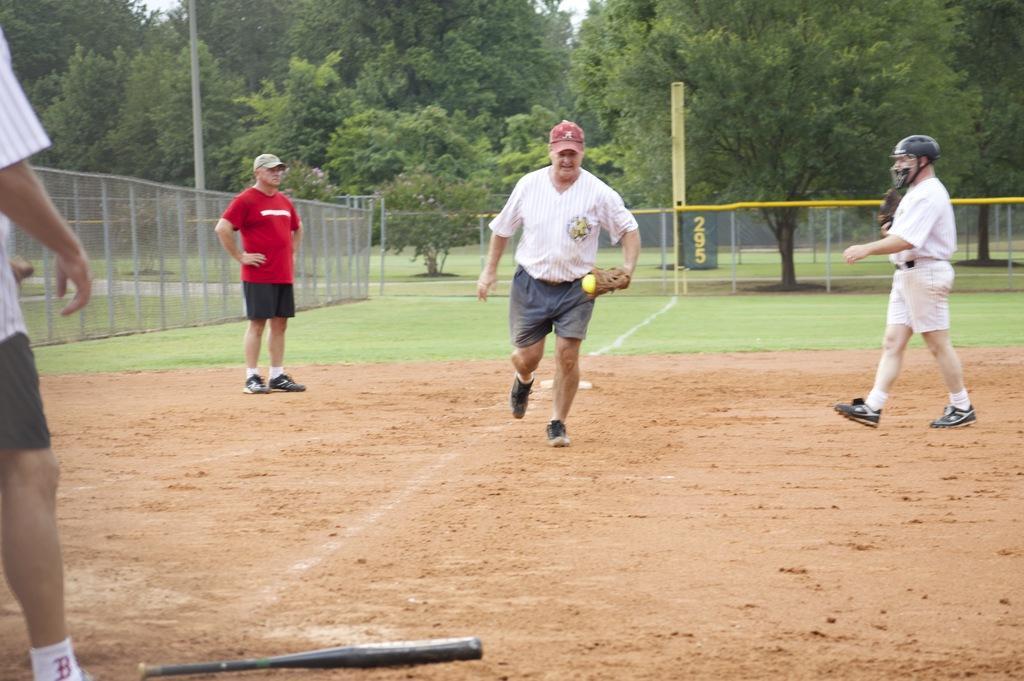Describe this image in one or two sentences. In this image I can see the ground, a baseball bat on the ground and few persons are standing on the ground. I can see a person is holding a ball in his hand. In the background I can see the metal fencing, few trees, few poles and the sky. 